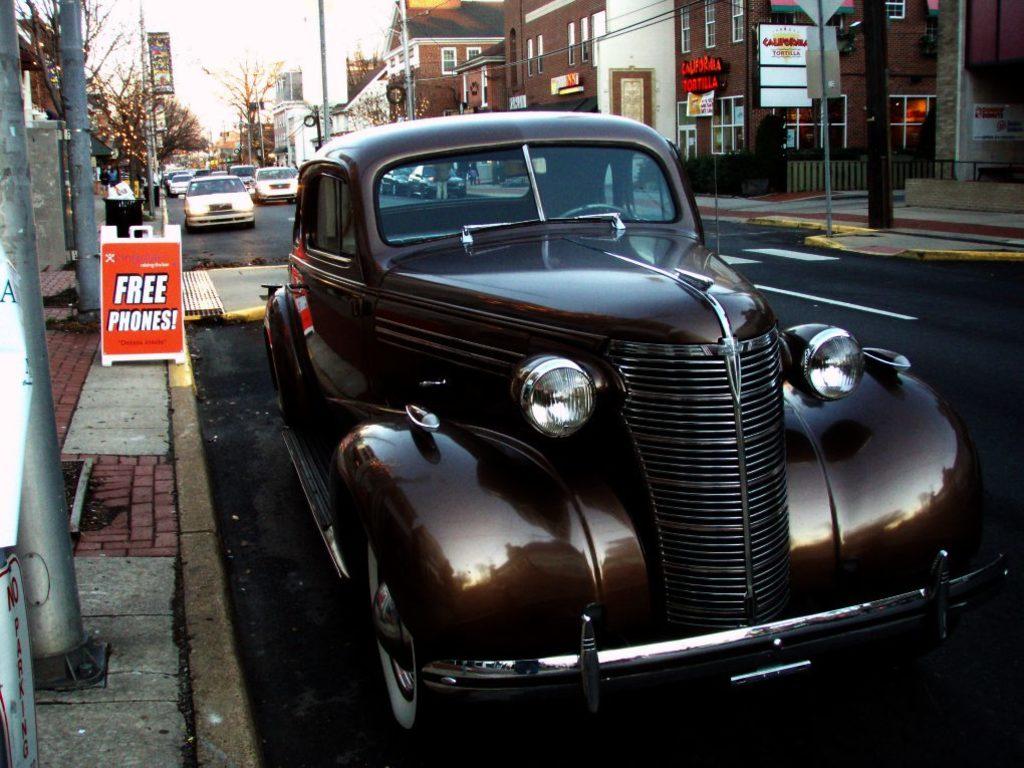What does the red sign say?
Provide a succinct answer. Free phones. What does the sign in the bottom left corner tell you not to do?
Your response must be concise. Park. 